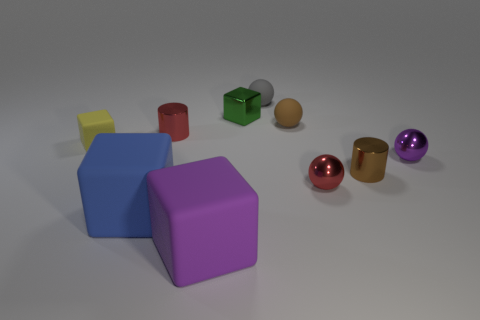Subtract all cyan balls. Subtract all green blocks. How many balls are left? 4 Subtract all blocks. How many objects are left? 6 Subtract all brown rubber spheres. Subtract all yellow rubber cubes. How many objects are left? 8 Add 6 cylinders. How many cylinders are left? 8 Add 2 yellow rubber cubes. How many yellow rubber cubes exist? 3 Subtract 0 green cylinders. How many objects are left? 10 